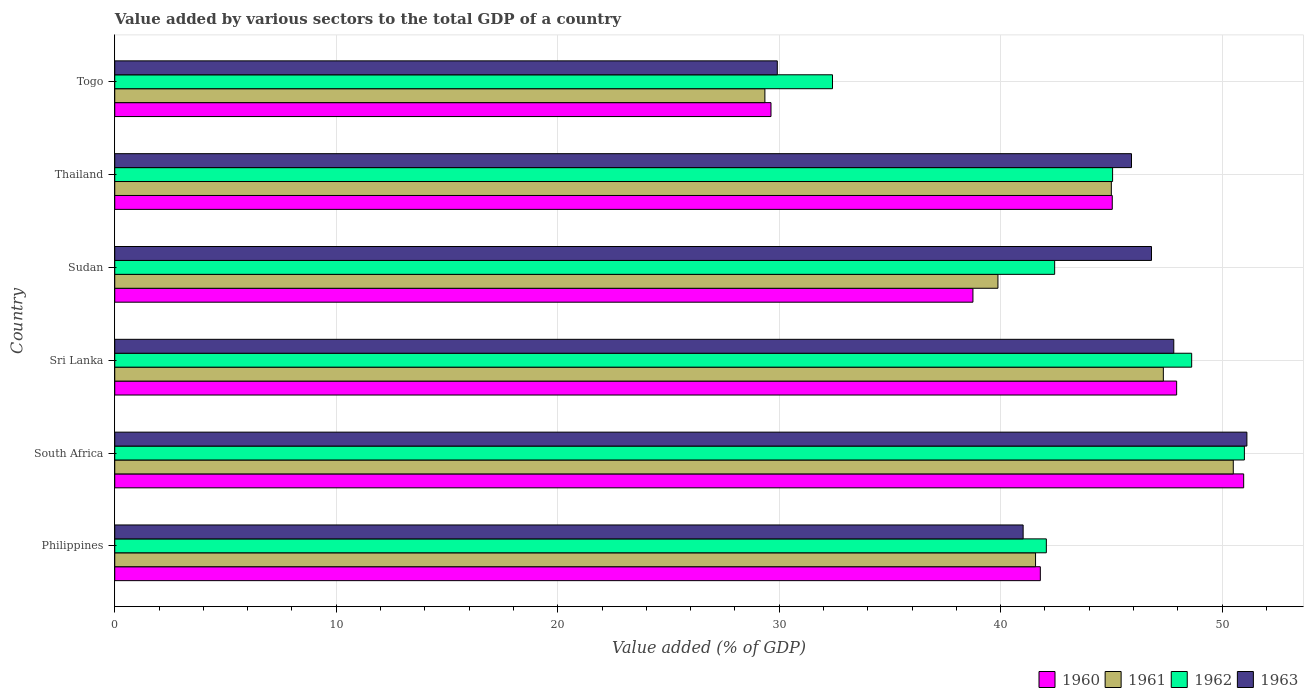How many groups of bars are there?
Make the answer very short. 6. Are the number of bars per tick equal to the number of legend labels?
Your response must be concise. Yes. Are the number of bars on each tick of the Y-axis equal?
Offer a terse response. Yes. How many bars are there on the 3rd tick from the top?
Ensure brevity in your answer.  4. What is the label of the 6th group of bars from the top?
Provide a succinct answer. Philippines. In how many cases, is the number of bars for a given country not equal to the number of legend labels?
Provide a short and direct response. 0. What is the value added by various sectors to the total GDP in 1962 in Togo?
Your response must be concise. 32.41. Across all countries, what is the maximum value added by various sectors to the total GDP in 1961?
Your answer should be compact. 50.5. Across all countries, what is the minimum value added by various sectors to the total GDP in 1961?
Your answer should be very brief. 29.35. In which country was the value added by various sectors to the total GDP in 1960 maximum?
Ensure brevity in your answer.  South Africa. In which country was the value added by various sectors to the total GDP in 1962 minimum?
Make the answer very short. Togo. What is the total value added by various sectors to the total GDP in 1961 in the graph?
Provide a succinct answer. 253.65. What is the difference between the value added by various sectors to the total GDP in 1962 in Philippines and that in Sri Lanka?
Make the answer very short. -6.56. What is the difference between the value added by various sectors to the total GDP in 1962 in Sri Lanka and the value added by various sectors to the total GDP in 1960 in Philippines?
Give a very brief answer. 6.83. What is the average value added by various sectors to the total GDP in 1960 per country?
Give a very brief answer. 42.35. What is the difference between the value added by various sectors to the total GDP in 1960 and value added by various sectors to the total GDP in 1962 in Sudan?
Offer a terse response. -3.69. What is the ratio of the value added by various sectors to the total GDP in 1961 in Sudan to that in Togo?
Make the answer very short. 1.36. Is the difference between the value added by various sectors to the total GDP in 1960 in Sri Lanka and Sudan greater than the difference between the value added by various sectors to the total GDP in 1962 in Sri Lanka and Sudan?
Offer a terse response. Yes. What is the difference between the highest and the second highest value added by various sectors to the total GDP in 1960?
Make the answer very short. 3.03. What is the difference between the highest and the lowest value added by various sectors to the total GDP in 1963?
Make the answer very short. 21.2. Is it the case that in every country, the sum of the value added by various sectors to the total GDP in 1960 and value added by various sectors to the total GDP in 1961 is greater than the value added by various sectors to the total GDP in 1963?
Provide a succinct answer. Yes. How many bars are there?
Ensure brevity in your answer.  24. How many countries are there in the graph?
Provide a short and direct response. 6. What is the title of the graph?
Ensure brevity in your answer.  Value added by various sectors to the total GDP of a country. Does "1985" appear as one of the legend labels in the graph?
Your answer should be compact. No. What is the label or title of the X-axis?
Keep it short and to the point. Value added (% of GDP). What is the label or title of the Y-axis?
Offer a very short reply. Country. What is the Value added (% of GDP) in 1960 in Philippines?
Provide a short and direct response. 41.79. What is the Value added (% of GDP) of 1961 in Philippines?
Your answer should be compact. 41.57. What is the Value added (% of GDP) of 1962 in Philippines?
Make the answer very short. 42.06. What is the Value added (% of GDP) in 1963 in Philippines?
Make the answer very short. 41.01. What is the Value added (% of GDP) of 1960 in South Africa?
Provide a short and direct response. 50.97. What is the Value added (% of GDP) in 1961 in South Africa?
Keep it short and to the point. 50.5. What is the Value added (% of GDP) in 1962 in South Africa?
Keep it short and to the point. 51.01. What is the Value added (% of GDP) in 1963 in South Africa?
Offer a terse response. 51.12. What is the Value added (% of GDP) of 1960 in Sri Lanka?
Offer a very short reply. 47.95. What is the Value added (% of GDP) in 1961 in Sri Lanka?
Provide a succinct answer. 47.35. What is the Value added (% of GDP) of 1962 in Sri Lanka?
Ensure brevity in your answer.  48.62. What is the Value added (% of GDP) of 1963 in Sri Lanka?
Keep it short and to the point. 47.82. What is the Value added (% of GDP) in 1960 in Sudan?
Offer a very short reply. 38.75. What is the Value added (% of GDP) in 1961 in Sudan?
Your response must be concise. 39.88. What is the Value added (% of GDP) of 1962 in Sudan?
Your answer should be very brief. 42.44. What is the Value added (% of GDP) in 1963 in Sudan?
Make the answer very short. 46.81. What is the Value added (% of GDP) of 1960 in Thailand?
Make the answer very short. 45.04. What is the Value added (% of GDP) of 1961 in Thailand?
Provide a short and direct response. 45. What is the Value added (% of GDP) of 1962 in Thailand?
Offer a terse response. 45.05. What is the Value added (% of GDP) of 1963 in Thailand?
Ensure brevity in your answer.  45.91. What is the Value added (% of GDP) in 1960 in Togo?
Ensure brevity in your answer.  29.63. What is the Value added (% of GDP) of 1961 in Togo?
Keep it short and to the point. 29.35. What is the Value added (% of GDP) of 1962 in Togo?
Give a very brief answer. 32.41. What is the Value added (% of GDP) of 1963 in Togo?
Make the answer very short. 29.91. Across all countries, what is the maximum Value added (% of GDP) of 1960?
Offer a very short reply. 50.97. Across all countries, what is the maximum Value added (% of GDP) of 1961?
Make the answer very short. 50.5. Across all countries, what is the maximum Value added (% of GDP) in 1962?
Ensure brevity in your answer.  51.01. Across all countries, what is the maximum Value added (% of GDP) in 1963?
Your answer should be very brief. 51.12. Across all countries, what is the minimum Value added (% of GDP) of 1960?
Give a very brief answer. 29.63. Across all countries, what is the minimum Value added (% of GDP) in 1961?
Your response must be concise. 29.35. Across all countries, what is the minimum Value added (% of GDP) of 1962?
Your response must be concise. 32.41. Across all countries, what is the minimum Value added (% of GDP) in 1963?
Provide a short and direct response. 29.91. What is the total Value added (% of GDP) in 1960 in the graph?
Give a very brief answer. 254.13. What is the total Value added (% of GDP) of 1961 in the graph?
Provide a succinct answer. 253.65. What is the total Value added (% of GDP) of 1962 in the graph?
Ensure brevity in your answer.  261.59. What is the total Value added (% of GDP) of 1963 in the graph?
Provide a short and direct response. 262.58. What is the difference between the Value added (% of GDP) in 1960 in Philippines and that in South Africa?
Make the answer very short. -9.18. What is the difference between the Value added (% of GDP) in 1961 in Philippines and that in South Africa?
Your response must be concise. -8.93. What is the difference between the Value added (% of GDP) of 1962 in Philippines and that in South Africa?
Give a very brief answer. -8.94. What is the difference between the Value added (% of GDP) in 1963 in Philippines and that in South Africa?
Offer a terse response. -10.1. What is the difference between the Value added (% of GDP) in 1960 in Philippines and that in Sri Lanka?
Ensure brevity in your answer.  -6.15. What is the difference between the Value added (% of GDP) in 1961 in Philippines and that in Sri Lanka?
Offer a very short reply. -5.77. What is the difference between the Value added (% of GDP) of 1962 in Philippines and that in Sri Lanka?
Ensure brevity in your answer.  -6.56. What is the difference between the Value added (% of GDP) in 1963 in Philippines and that in Sri Lanka?
Give a very brief answer. -6.8. What is the difference between the Value added (% of GDP) in 1960 in Philippines and that in Sudan?
Your response must be concise. 3.04. What is the difference between the Value added (% of GDP) of 1961 in Philippines and that in Sudan?
Your answer should be compact. 1.7. What is the difference between the Value added (% of GDP) of 1962 in Philippines and that in Sudan?
Offer a terse response. -0.38. What is the difference between the Value added (% of GDP) in 1963 in Philippines and that in Sudan?
Make the answer very short. -5.8. What is the difference between the Value added (% of GDP) in 1960 in Philippines and that in Thailand?
Make the answer very short. -3.25. What is the difference between the Value added (% of GDP) of 1961 in Philippines and that in Thailand?
Provide a short and direct response. -3.42. What is the difference between the Value added (% of GDP) in 1962 in Philippines and that in Thailand?
Your answer should be compact. -2.99. What is the difference between the Value added (% of GDP) in 1963 in Philippines and that in Thailand?
Provide a short and direct response. -4.89. What is the difference between the Value added (% of GDP) of 1960 in Philippines and that in Togo?
Provide a succinct answer. 12.16. What is the difference between the Value added (% of GDP) in 1961 in Philippines and that in Togo?
Offer a terse response. 12.22. What is the difference between the Value added (% of GDP) in 1962 in Philippines and that in Togo?
Provide a succinct answer. 9.66. What is the difference between the Value added (% of GDP) of 1963 in Philippines and that in Togo?
Provide a short and direct response. 11.1. What is the difference between the Value added (% of GDP) of 1960 in South Africa and that in Sri Lanka?
Make the answer very short. 3.03. What is the difference between the Value added (% of GDP) in 1961 in South Africa and that in Sri Lanka?
Your response must be concise. 3.16. What is the difference between the Value added (% of GDP) in 1962 in South Africa and that in Sri Lanka?
Your answer should be very brief. 2.38. What is the difference between the Value added (% of GDP) of 1963 in South Africa and that in Sri Lanka?
Make the answer very short. 3.3. What is the difference between the Value added (% of GDP) of 1960 in South Africa and that in Sudan?
Your answer should be very brief. 12.22. What is the difference between the Value added (% of GDP) in 1961 in South Africa and that in Sudan?
Provide a short and direct response. 10.63. What is the difference between the Value added (% of GDP) in 1962 in South Africa and that in Sudan?
Give a very brief answer. 8.57. What is the difference between the Value added (% of GDP) of 1963 in South Africa and that in Sudan?
Your answer should be very brief. 4.31. What is the difference between the Value added (% of GDP) of 1960 in South Africa and that in Thailand?
Offer a very short reply. 5.93. What is the difference between the Value added (% of GDP) of 1961 in South Africa and that in Thailand?
Your response must be concise. 5.51. What is the difference between the Value added (% of GDP) in 1962 in South Africa and that in Thailand?
Provide a short and direct response. 5.95. What is the difference between the Value added (% of GDP) in 1963 in South Africa and that in Thailand?
Provide a succinct answer. 5.21. What is the difference between the Value added (% of GDP) of 1960 in South Africa and that in Togo?
Offer a terse response. 21.34. What is the difference between the Value added (% of GDP) in 1961 in South Africa and that in Togo?
Offer a terse response. 21.15. What is the difference between the Value added (% of GDP) of 1962 in South Africa and that in Togo?
Provide a short and direct response. 18.6. What is the difference between the Value added (% of GDP) of 1963 in South Africa and that in Togo?
Make the answer very short. 21.2. What is the difference between the Value added (% of GDP) in 1960 in Sri Lanka and that in Sudan?
Offer a very short reply. 9.2. What is the difference between the Value added (% of GDP) in 1961 in Sri Lanka and that in Sudan?
Make the answer very short. 7.47. What is the difference between the Value added (% of GDP) of 1962 in Sri Lanka and that in Sudan?
Keep it short and to the point. 6.19. What is the difference between the Value added (% of GDP) in 1960 in Sri Lanka and that in Thailand?
Make the answer very short. 2.91. What is the difference between the Value added (% of GDP) of 1961 in Sri Lanka and that in Thailand?
Your answer should be very brief. 2.35. What is the difference between the Value added (% of GDP) of 1962 in Sri Lanka and that in Thailand?
Provide a short and direct response. 3.57. What is the difference between the Value added (% of GDP) in 1963 in Sri Lanka and that in Thailand?
Offer a very short reply. 1.91. What is the difference between the Value added (% of GDP) in 1960 in Sri Lanka and that in Togo?
Keep it short and to the point. 18.32. What is the difference between the Value added (% of GDP) of 1961 in Sri Lanka and that in Togo?
Your response must be concise. 17.99. What is the difference between the Value added (% of GDP) of 1962 in Sri Lanka and that in Togo?
Your response must be concise. 16.22. What is the difference between the Value added (% of GDP) of 1963 in Sri Lanka and that in Togo?
Your answer should be very brief. 17.9. What is the difference between the Value added (% of GDP) in 1960 in Sudan and that in Thailand?
Your answer should be very brief. -6.29. What is the difference between the Value added (% of GDP) in 1961 in Sudan and that in Thailand?
Offer a very short reply. -5.12. What is the difference between the Value added (% of GDP) in 1962 in Sudan and that in Thailand?
Ensure brevity in your answer.  -2.62. What is the difference between the Value added (% of GDP) of 1963 in Sudan and that in Thailand?
Make the answer very short. 0.9. What is the difference between the Value added (% of GDP) of 1960 in Sudan and that in Togo?
Your answer should be compact. 9.12. What is the difference between the Value added (% of GDP) in 1961 in Sudan and that in Togo?
Your answer should be compact. 10.52. What is the difference between the Value added (% of GDP) in 1962 in Sudan and that in Togo?
Give a very brief answer. 10.03. What is the difference between the Value added (% of GDP) of 1963 in Sudan and that in Togo?
Ensure brevity in your answer.  16.9. What is the difference between the Value added (% of GDP) in 1960 in Thailand and that in Togo?
Your answer should be very brief. 15.41. What is the difference between the Value added (% of GDP) in 1961 in Thailand and that in Togo?
Your answer should be very brief. 15.64. What is the difference between the Value added (% of GDP) of 1962 in Thailand and that in Togo?
Your response must be concise. 12.65. What is the difference between the Value added (% of GDP) in 1963 in Thailand and that in Togo?
Provide a short and direct response. 15.99. What is the difference between the Value added (% of GDP) of 1960 in Philippines and the Value added (% of GDP) of 1961 in South Africa?
Your answer should be very brief. -8.71. What is the difference between the Value added (% of GDP) in 1960 in Philippines and the Value added (% of GDP) in 1962 in South Africa?
Ensure brevity in your answer.  -9.21. What is the difference between the Value added (% of GDP) of 1960 in Philippines and the Value added (% of GDP) of 1963 in South Africa?
Ensure brevity in your answer.  -9.33. What is the difference between the Value added (% of GDP) in 1961 in Philippines and the Value added (% of GDP) in 1962 in South Africa?
Offer a terse response. -9.43. What is the difference between the Value added (% of GDP) in 1961 in Philippines and the Value added (% of GDP) in 1963 in South Africa?
Keep it short and to the point. -9.54. What is the difference between the Value added (% of GDP) in 1962 in Philippines and the Value added (% of GDP) in 1963 in South Africa?
Keep it short and to the point. -9.05. What is the difference between the Value added (% of GDP) of 1960 in Philippines and the Value added (% of GDP) of 1961 in Sri Lanka?
Your answer should be compact. -5.55. What is the difference between the Value added (% of GDP) in 1960 in Philippines and the Value added (% of GDP) in 1962 in Sri Lanka?
Offer a very short reply. -6.83. What is the difference between the Value added (% of GDP) in 1960 in Philippines and the Value added (% of GDP) in 1963 in Sri Lanka?
Your response must be concise. -6.03. What is the difference between the Value added (% of GDP) of 1961 in Philippines and the Value added (% of GDP) of 1962 in Sri Lanka?
Your answer should be very brief. -7.05. What is the difference between the Value added (% of GDP) in 1961 in Philippines and the Value added (% of GDP) in 1963 in Sri Lanka?
Offer a very short reply. -6.24. What is the difference between the Value added (% of GDP) in 1962 in Philippines and the Value added (% of GDP) in 1963 in Sri Lanka?
Your answer should be very brief. -5.75. What is the difference between the Value added (% of GDP) in 1960 in Philippines and the Value added (% of GDP) in 1961 in Sudan?
Make the answer very short. 1.91. What is the difference between the Value added (% of GDP) of 1960 in Philippines and the Value added (% of GDP) of 1962 in Sudan?
Give a very brief answer. -0.65. What is the difference between the Value added (% of GDP) of 1960 in Philippines and the Value added (% of GDP) of 1963 in Sudan?
Your answer should be compact. -5.02. What is the difference between the Value added (% of GDP) of 1961 in Philippines and the Value added (% of GDP) of 1962 in Sudan?
Make the answer very short. -0.86. What is the difference between the Value added (% of GDP) in 1961 in Philippines and the Value added (% of GDP) in 1963 in Sudan?
Offer a very short reply. -5.24. What is the difference between the Value added (% of GDP) of 1962 in Philippines and the Value added (% of GDP) of 1963 in Sudan?
Your answer should be very brief. -4.75. What is the difference between the Value added (% of GDP) in 1960 in Philippines and the Value added (% of GDP) in 1961 in Thailand?
Offer a terse response. -3.21. What is the difference between the Value added (% of GDP) of 1960 in Philippines and the Value added (% of GDP) of 1962 in Thailand?
Offer a very short reply. -3.26. What is the difference between the Value added (% of GDP) in 1960 in Philippines and the Value added (% of GDP) in 1963 in Thailand?
Make the answer very short. -4.12. What is the difference between the Value added (% of GDP) in 1961 in Philippines and the Value added (% of GDP) in 1962 in Thailand?
Provide a succinct answer. -3.48. What is the difference between the Value added (% of GDP) of 1961 in Philippines and the Value added (% of GDP) of 1963 in Thailand?
Your answer should be compact. -4.33. What is the difference between the Value added (% of GDP) in 1962 in Philippines and the Value added (% of GDP) in 1963 in Thailand?
Keep it short and to the point. -3.84. What is the difference between the Value added (% of GDP) in 1960 in Philippines and the Value added (% of GDP) in 1961 in Togo?
Ensure brevity in your answer.  12.44. What is the difference between the Value added (% of GDP) of 1960 in Philippines and the Value added (% of GDP) of 1962 in Togo?
Offer a terse response. 9.38. What is the difference between the Value added (% of GDP) of 1960 in Philippines and the Value added (% of GDP) of 1963 in Togo?
Your answer should be very brief. 11.88. What is the difference between the Value added (% of GDP) of 1961 in Philippines and the Value added (% of GDP) of 1962 in Togo?
Make the answer very short. 9.17. What is the difference between the Value added (% of GDP) of 1961 in Philippines and the Value added (% of GDP) of 1963 in Togo?
Offer a terse response. 11.66. What is the difference between the Value added (% of GDP) in 1962 in Philippines and the Value added (% of GDP) in 1963 in Togo?
Give a very brief answer. 12.15. What is the difference between the Value added (% of GDP) in 1960 in South Africa and the Value added (% of GDP) in 1961 in Sri Lanka?
Your response must be concise. 3.63. What is the difference between the Value added (% of GDP) in 1960 in South Africa and the Value added (% of GDP) in 1962 in Sri Lanka?
Provide a succinct answer. 2.35. What is the difference between the Value added (% of GDP) of 1960 in South Africa and the Value added (% of GDP) of 1963 in Sri Lanka?
Your answer should be very brief. 3.16. What is the difference between the Value added (% of GDP) of 1961 in South Africa and the Value added (% of GDP) of 1962 in Sri Lanka?
Ensure brevity in your answer.  1.88. What is the difference between the Value added (% of GDP) in 1961 in South Africa and the Value added (% of GDP) in 1963 in Sri Lanka?
Offer a very short reply. 2.69. What is the difference between the Value added (% of GDP) of 1962 in South Africa and the Value added (% of GDP) of 1963 in Sri Lanka?
Your answer should be compact. 3.19. What is the difference between the Value added (% of GDP) in 1960 in South Africa and the Value added (% of GDP) in 1961 in Sudan?
Your answer should be very brief. 11.09. What is the difference between the Value added (% of GDP) in 1960 in South Africa and the Value added (% of GDP) in 1962 in Sudan?
Keep it short and to the point. 8.53. What is the difference between the Value added (% of GDP) in 1960 in South Africa and the Value added (% of GDP) in 1963 in Sudan?
Offer a terse response. 4.16. What is the difference between the Value added (% of GDP) of 1961 in South Africa and the Value added (% of GDP) of 1962 in Sudan?
Offer a very short reply. 8.07. What is the difference between the Value added (% of GDP) in 1961 in South Africa and the Value added (% of GDP) in 1963 in Sudan?
Your answer should be very brief. 3.69. What is the difference between the Value added (% of GDP) in 1962 in South Africa and the Value added (% of GDP) in 1963 in Sudan?
Give a very brief answer. 4.19. What is the difference between the Value added (% of GDP) of 1960 in South Africa and the Value added (% of GDP) of 1961 in Thailand?
Ensure brevity in your answer.  5.98. What is the difference between the Value added (% of GDP) in 1960 in South Africa and the Value added (% of GDP) in 1962 in Thailand?
Your response must be concise. 5.92. What is the difference between the Value added (% of GDP) of 1960 in South Africa and the Value added (% of GDP) of 1963 in Thailand?
Your response must be concise. 5.06. What is the difference between the Value added (% of GDP) of 1961 in South Africa and the Value added (% of GDP) of 1962 in Thailand?
Offer a terse response. 5.45. What is the difference between the Value added (% of GDP) in 1961 in South Africa and the Value added (% of GDP) in 1963 in Thailand?
Your answer should be very brief. 4.6. What is the difference between the Value added (% of GDP) in 1962 in South Africa and the Value added (% of GDP) in 1963 in Thailand?
Provide a short and direct response. 5.1. What is the difference between the Value added (% of GDP) in 1960 in South Africa and the Value added (% of GDP) in 1961 in Togo?
Your answer should be very brief. 21.62. What is the difference between the Value added (% of GDP) of 1960 in South Africa and the Value added (% of GDP) of 1962 in Togo?
Offer a terse response. 18.56. What is the difference between the Value added (% of GDP) of 1960 in South Africa and the Value added (% of GDP) of 1963 in Togo?
Keep it short and to the point. 21.06. What is the difference between the Value added (% of GDP) in 1961 in South Africa and the Value added (% of GDP) in 1962 in Togo?
Offer a terse response. 18.1. What is the difference between the Value added (% of GDP) of 1961 in South Africa and the Value added (% of GDP) of 1963 in Togo?
Your response must be concise. 20.59. What is the difference between the Value added (% of GDP) in 1962 in South Africa and the Value added (% of GDP) in 1963 in Togo?
Keep it short and to the point. 21.09. What is the difference between the Value added (% of GDP) of 1960 in Sri Lanka and the Value added (% of GDP) of 1961 in Sudan?
Make the answer very short. 8.07. What is the difference between the Value added (% of GDP) of 1960 in Sri Lanka and the Value added (% of GDP) of 1962 in Sudan?
Provide a short and direct response. 5.51. What is the difference between the Value added (% of GDP) of 1960 in Sri Lanka and the Value added (% of GDP) of 1963 in Sudan?
Offer a very short reply. 1.14. What is the difference between the Value added (% of GDP) in 1961 in Sri Lanka and the Value added (% of GDP) in 1962 in Sudan?
Offer a very short reply. 4.91. What is the difference between the Value added (% of GDP) in 1961 in Sri Lanka and the Value added (% of GDP) in 1963 in Sudan?
Offer a very short reply. 0.53. What is the difference between the Value added (% of GDP) in 1962 in Sri Lanka and the Value added (% of GDP) in 1963 in Sudan?
Your response must be concise. 1.81. What is the difference between the Value added (% of GDP) of 1960 in Sri Lanka and the Value added (% of GDP) of 1961 in Thailand?
Ensure brevity in your answer.  2.95. What is the difference between the Value added (% of GDP) in 1960 in Sri Lanka and the Value added (% of GDP) in 1962 in Thailand?
Provide a succinct answer. 2.89. What is the difference between the Value added (% of GDP) in 1960 in Sri Lanka and the Value added (% of GDP) in 1963 in Thailand?
Keep it short and to the point. 2.04. What is the difference between the Value added (% of GDP) in 1961 in Sri Lanka and the Value added (% of GDP) in 1962 in Thailand?
Ensure brevity in your answer.  2.29. What is the difference between the Value added (% of GDP) in 1961 in Sri Lanka and the Value added (% of GDP) in 1963 in Thailand?
Your answer should be compact. 1.44. What is the difference between the Value added (% of GDP) in 1962 in Sri Lanka and the Value added (% of GDP) in 1963 in Thailand?
Provide a short and direct response. 2.72. What is the difference between the Value added (% of GDP) of 1960 in Sri Lanka and the Value added (% of GDP) of 1961 in Togo?
Offer a very short reply. 18.59. What is the difference between the Value added (% of GDP) in 1960 in Sri Lanka and the Value added (% of GDP) in 1962 in Togo?
Offer a terse response. 15.54. What is the difference between the Value added (% of GDP) of 1960 in Sri Lanka and the Value added (% of GDP) of 1963 in Togo?
Offer a terse response. 18.03. What is the difference between the Value added (% of GDP) in 1961 in Sri Lanka and the Value added (% of GDP) in 1962 in Togo?
Your answer should be compact. 14.94. What is the difference between the Value added (% of GDP) of 1961 in Sri Lanka and the Value added (% of GDP) of 1963 in Togo?
Provide a short and direct response. 17.43. What is the difference between the Value added (% of GDP) in 1962 in Sri Lanka and the Value added (% of GDP) in 1963 in Togo?
Keep it short and to the point. 18.71. What is the difference between the Value added (% of GDP) in 1960 in Sudan and the Value added (% of GDP) in 1961 in Thailand?
Your response must be concise. -6.25. What is the difference between the Value added (% of GDP) of 1960 in Sudan and the Value added (% of GDP) of 1962 in Thailand?
Provide a short and direct response. -6.31. What is the difference between the Value added (% of GDP) in 1960 in Sudan and the Value added (% of GDP) in 1963 in Thailand?
Offer a very short reply. -7.16. What is the difference between the Value added (% of GDP) in 1961 in Sudan and the Value added (% of GDP) in 1962 in Thailand?
Your answer should be compact. -5.18. What is the difference between the Value added (% of GDP) of 1961 in Sudan and the Value added (% of GDP) of 1963 in Thailand?
Your answer should be compact. -6.03. What is the difference between the Value added (% of GDP) of 1962 in Sudan and the Value added (% of GDP) of 1963 in Thailand?
Your answer should be compact. -3.47. What is the difference between the Value added (% of GDP) of 1960 in Sudan and the Value added (% of GDP) of 1961 in Togo?
Your response must be concise. 9.39. What is the difference between the Value added (% of GDP) in 1960 in Sudan and the Value added (% of GDP) in 1962 in Togo?
Your answer should be very brief. 6.34. What is the difference between the Value added (% of GDP) of 1960 in Sudan and the Value added (% of GDP) of 1963 in Togo?
Keep it short and to the point. 8.83. What is the difference between the Value added (% of GDP) in 1961 in Sudan and the Value added (% of GDP) in 1962 in Togo?
Your answer should be very brief. 7.47. What is the difference between the Value added (% of GDP) of 1961 in Sudan and the Value added (% of GDP) of 1963 in Togo?
Your response must be concise. 9.96. What is the difference between the Value added (% of GDP) in 1962 in Sudan and the Value added (% of GDP) in 1963 in Togo?
Keep it short and to the point. 12.52. What is the difference between the Value added (% of GDP) in 1960 in Thailand and the Value added (% of GDP) in 1961 in Togo?
Keep it short and to the point. 15.68. What is the difference between the Value added (% of GDP) in 1960 in Thailand and the Value added (% of GDP) in 1962 in Togo?
Provide a succinct answer. 12.63. What is the difference between the Value added (% of GDP) of 1960 in Thailand and the Value added (% of GDP) of 1963 in Togo?
Offer a very short reply. 15.12. What is the difference between the Value added (% of GDP) of 1961 in Thailand and the Value added (% of GDP) of 1962 in Togo?
Ensure brevity in your answer.  12.59. What is the difference between the Value added (% of GDP) of 1961 in Thailand and the Value added (% of GDP) of 1963 in Togo?
Provide a short and direct response. 15.08. What is the difference between the Value added (% of GDP) of 1962 in Thailand and the Value added (% of GDP) of 1963 in Togo?
Your answer should be very brief. 15.14. What is the average Value added (% of GDP) of 1960 per country?
Make the answer very short. 42.35. What is the average Value added (% of GDP) in 1961 per country?
Make the answer very short. 42.28. What is the average Value added (% of GDP) of 1962 per country?
Offer a very short reply. 43.6. What is the average Value added (% of GDP) of 1963 per country?
Give a very brief answer. 43.76. What is the difference between the Value added (% of GDP) in 1960 and Value added (% of GDP) in 1961 in Philippines?
Make the answer very short. 0.22. What is the difference between the Value added (% of GDP) of 1960 and Value added (% of GDP) of 1962 in Philippines?
Offer a very short reply. -0.27. What is the difference between the Value added (% of GDP) in 1960 and Value added (% of GDP) in 1963 in Philippines?
Your answer should be compact. 0.78. What is the difference between the Value added (% of GDP) of 1961 and Value added (% of GDP) of 1962 in Philippines?
Offer a very short reply. -0.49. What is the difference between the Value added (% of GDP) of 1961 and Value added (% of GDP) of 1963 in Philippines?
Make the answer very short. 0.56. What is the difference between the Value added (% of GDP) of 1962 and Value added (% of GDP) of 1963 in Philippines?
Ensure brevity in your answer.  1.05. What is the difference between the Value added (% of GDP) of 1960 and Value added (% of GDP) of 1961 in South Africa?
Your answer should be compact. 0.47. What is the difference between the Value added (% of GDP) in 1960 and Value added (% of GDP) in 1962 in South Africa?
Keep it short and to the point. -0.03. What is the difference between the Value added (% of GDP) in 1960 and Value added (% of GDP) in 1963 in South Africa?
Your response must be concise. -0.15. What is the difference between the Value added (% of GDP) in 1961 and Value added (% of GDP) in 1962 in South Africa?
Give a very brief answer. -0.5. What is the difference between the Value added (% of GDP) of 1961 and Value added (% of GDP) of 1963 in South Africa?
Your response must be concise. -0.61. What is the difference between the Value added (% of GDP) of 1962 and Value added (% of GDP) of 1963 in South Africa?
Your answer should be compact. -0.11. What is the difference between the Value added (% of GDP) in 1960 and Value added (% of GDP) in 1961 in Sri Lanka?
Offer a very short reply. 0.6. What is the difference between the Value added (% of GDP) in 1960 and Value added (% of GDP) in 1962 in Sri Lanka?
Give a very brief answer. -0.68. What is the difference between the Value added (% of GDP) in 1960 and Value added (% of GDP) in 1963 in Sri Lanka?
Your response must be concise. 0.13. What is the difference between the Value added (% of GDP) of 1961 and Value added (% of GDP) of 1962 in Sri Lanka?
Keep it short and to the point. -1.28. What is the difference between the Value added (% of GDP) in 1961 and Value added (% of GDP) in 1963 in Sri Lanka?
Your answer should be compact. -0.47. What is the difference between the Value added (% of GDP) of 1962 and Value added (% of GDP) of 1963 in Sri Lanka?
Make the answer very short. 0.81. What is the difference between the Value added (% of GDP) of 1960 and Value added (% of GDP) of 1961 in Sudan?
Ensure brevity in your answer.  -1.13. What is the difference between the Value added (% of GDP) in 1960 and Value added (% of GDP) in 1962 in Sudan?
Your response must be concise. -3.69. What is the difference between the Value added (% of GDP) of 1960 and Value added (% of GDP) of 1963 in Sudan?
Make the answer very short. -8.06. What is the difference between the Value added (% of GDP) in 1961 and Value added (% of GDP) in 1962 in Sudan?
Ensure brevity in your answer.  -2.56. What is the difference between the Value added (% of GDP) of 1961 and Value added (% of GDP) of 1963 in Sudan?
Your answer should be compact. -6.93. What is the difference between the Value added (% of GDP) in 1962 and Value added (% of GDP) in 1963 in Sudan?
Your answer should be compact. -4.37. What is the difference between the Value added (% of GDP) of 1960 and Value added (% of GDP) of 1961 in Thailand?
Offer a very short reply. 0.04. What is the difference between the Value added (% of GDP) in 1960 and Value added (% of GDP) in 1962 in Thailand?
Your answer should be very brief. -0.02. What is the difference between the Value added (% of GDP) of 1960 and Value added (% of GDP) of 1963 in Thailand?
Your response must be concise. -0.87. What is the difference between the Value added (% of GDP) in 1961 and Value added (% of GDP) in 1962 in Thailand?
Offer a terse response. -0.06. What is the difference between the Value added (% of GDP) in 1961 and Value added (% of GDP) in 1963 in Thailand?
Ensure brevity in your answer.  -0.91. What is the difference between the Value added (% of GDP) of 1962 and Value added (% of GDP) of 1963 in Thailand?
Your answer should be very brief. -0.85. What is the difference between the Value added (% of GDP) of 1960 and Value added (% of GDP) of 1961 in Togo?
Offer a very short reply. 0.27. What is the difference between the Value added (% of GDP) of 1960 and Value added (% of GDP) of 1962 in Togo?
Keep it short and to the point. -2.78. What is the difference between the Value added (% of GDP) in 1960 and Value added (% of GDP) in 1963 in Togo?
Keep it short and to the point. -0.28. What is the difference between the Value added (% of GDP) in 1961 and Value added (% of GDP) in 1962 in Togo?
Your answer should be compact. -3.05. What is the difference between the Value added (% of GDP) in 1961 and Value added (% of GDP) in 1963 in Togo?
Offer a very short reply. -0.56. What is the difference between the Value added (% of GDP) in 1962 and Value added (% of GDP) in 1963 in Togo?
Your response must be concise. 2.49. What is the ratio of the Value added (% of GDP) in 1960 in Philippines to that in South Africa?
Provide a short and direct response. 0.82. What is the ratio of the Value added (% of GDP) of 1961 in Philippines to that in South Africa?
Give a very brief answer. 0.82. What is the ratio of the Value added (% of GDP) in 1962 in Philippines to that in South Africa?
Your response must be concise. 0.82. What is the ratio of the Value added (% of GDP) in 1963 in Philippines to that in South Africa?
Your answer should be compact. 0.8. What is the ratio of the Value added (% of GDP) in 1960 in Philippines to that in Sri Lanka?
Give a very brief answer. 0.87. What is the ratio of the Value added (% of GDP) in 1961 in Philippines to that in Sri Lanka?
Your answer should be compact. 0.88. What is the ratio of the Value added (% of GDP) in 1962 in Philippines to that in Sri Lanka?
Offer a very short reply. 0.87. What is the ratio of the Value added (% of GDP) of 1963 in Philippines to that in Sri Lanka?
Keep it short and to the point. 0.86. What is the ratio of the Value added (% of GDP) in 1960 in Philippines to that in Sudan?
Provide a succinct answer. 1.08. What is the ratio of the Value added (% of GDP) of 1961 in Philippines to that in Sudan?
Give a very brief answer. 1.04. What is the ratio of the Value added (% of GDP) of 1963 in Philippines to that in Sudan?
Offer a terse response. 0.88. What is the ratio of the Value added (% of GDP) of 1960 in Philippines to that in Thailand?
Make the answer very short. 0.93. What is the ratio of the Value added (% of GDP) of 1961 in Philippines to that in Thailand?
Your answer should be very brief. 0.92. What is the ratio of the Value added (% of GDP) in 1962 in Philippines to that in Thailand?
Give a very brief answer. 0.93. What is the ratio of the Value added (% of GDP) in 1963 in Philippines to that in Thailand?
Your answer should be very brief. 0.89. What is the ratio of the Value added (% of GDP) in 1960 in Philippines to that in Togo?
Make the answer very short. 1.41. What is the ratio of the Value added (% of GDP) of 1961 in Philippines to that in Togo?
Give a very brief answer. 1.42. What is the ratio of the Value added (% of GDP) of 1962 in Philippines to that in Togo?
Make the answer very short. 1.3. What is the ratio of the Value added (% of GDP) in 1963 in Philippines to that in Togo?
Your response must be concise. 1.37. What is the ratio of the Value added (% of GDP) of 1960 in South Africa to that in Sri Lanka?
Your response must be concise. 1.06. What is the ratio of the Value added (% of GDP) of 1961 in South Africa to that in Sri Lanka?
Keep it short and to the point. 1.07. What is the ratio of the Value added (% of GDP) of 1962 in South Africa to that in Sri Lanka?
Offer a terse response. 1.05. What is the ratio of the Value added (% of GDP) of 1963 in South Africa to that in Sri Lanka?
Offer a very short reply. 1.07. What is the ratio of the Value added (% of GDP) in 1960 in South Africa to that in Sudan?
Provide a short and direct response. 1.32. What is the ratio of the Value added (% of GDP) in 1961 in South Africa to that in Sudan?
Your response must be concise. 1.27. What is the ratio of the Value added (% of GDP) of 1962 in South Africa to that in Sudan?
Provide a succinct answer. 1.2. What is the ratio of the Value added (% of GDP) of 1963 in South Africa to that in Sudan?
Keep it short and to the point. 1.09. What is the ratio of the Value added (% of GDP) of 1960 in South Africa to that in Thailand?
Your answer should be compact. 1.13. What is the ratio of the Value added (% of GDP) in 1961 in South Africa to that in Thailand?
Give a very brief answer. 1.12. What is the ratio of the Value added (% of GDP) in 1962 in South Africa to that in Thailand?
Provide a succinct answer. 1.13. What is the ratio of the Value added (% of GDP) of 1963 in South Africa to that in Thailand?
Provide a short and direct response. 1.11. What is the ratio of the Value added (% of GDP) in 1960 in South Africa to that in Togo?
Ensure brevity in your answer.  1.72. What is the ratio of the Value added (% of GDP) of 1961 in South Africa to that in Togo?
Your answer should be very brief. 1.72. What is the ratio of the Value added (% of GDP) of 1962 in South Africa to that in Togo?
Provide a short and direct response. 1.57. What is the ratio of the Value added (% of GDP) in 1963 in South Africa to that in Togo?
Give a very brief answer. 1.71. What is the ratio of the Value added (% of GDP) in 1960 in Sri Lanka to that in Sudan?
Your answer should be compact. 1.24. What is the ratio of the Value added (% of GDP) in 1961 in Sri Lanka to that in Sudan?
Your response must be concise. 1.19. What is the ratio of the Value added (% of GDP) of 1962 in Sri Lanka to that in Sudan?
Ensure brevity in your answer.  1.15. What is the ratio of the Value added (% of GDP) in 1963 in Sri Lanka to that in Sudan?
Offer a terse response. 1.02. What is the ratio of the Value added (% of GDP) in 1960 in Sri Lanka to that in Thailand?
Your response must be concise. 1.06. What is the ratio of the Value added (% of GDP) of 1961 in Sri Lanka to that in Thailand?
Your answer should be very brief. 1.05. What is the ratio of the Value added (% of GDP) in 1962 in Sri Lanka to that in Thailand?
Give a very brief answer. 1.08. What is the ratio of the Value added (% of GDP) of 1963 in Sri Lanka to that in Thailand?
Keep it short and to the point. 1.04. What is the ratio of the Value added (% of GDP) of 1960 in Sri Lanka to that in Togo?
Your answer should be compact. 1.62. What is the ratio of the Value added (% of GDP) of 1961 in Sri Lanka to that in Togo?
Make the answer very short. 1.61. What is the ratio of the Value added (% of GDP) in 1962 in Sri Lanka to that in Togo?
Your response must be concise. 1.5. What is the ratio of the Value added (% of GDP) of 1963 in Sri Lanka to that in Togo?
Your answer should be very brief. 1.6. What is the ratio of the Value added (% of GDP) in 1960 in Sudan to that in Thailand?
Keep it short and to the point. 0.86. What is the ratio of the Value added (% of GDP) in 1961 in Sudan to that in Thailand?
Offer a very short reply. 0.89. What is the ratio of the Value added (% of GDP) in 1962 in Sudan to that in Thailand?
Give a very brief answer. 0.94. What is the ratio of the Value added (% of GDP) of 1963 in Sudan to that in Thailand?
Your answer should be compact. 1.02. What is the ratio of the Value added (% of GDP) in 1960 in Sudan to that in Togo?
Keep it short and to the point. 1.31. What is the ratio of the Value added (% of GDP) of 1961 in Sudan to that in Togo?
Keep it short and to the point. 1.36. What is the ratio of the Value added (% of GDP) of 1962 in Sudan to that in Togo?
Your response must be concise. 1.31. What is the ratio of the Value added (% of GDP) of 1963 in Sudan to that in Togo?
Ensure brevity in your answer.  1.56. What is the ratio of the Value added (% of GDP) of 1960 in Thailand to that in Togo?
Offer a terse response. 1.52. What is the ratio of the Value added (% of GDP) in 1961 in Thailand to that in Togo?
Provide a short and direct response. 1.53. What is the ratio of the Value added (% of GDP) of 1962 in Thailand to that in Togo?
Make the answer very short. 1.39. What is the ratio of the Value added (% of GDP) of 1963 in Thailand to that in Togo?
Ensure brevity in your answer.  1.53. What is the difference between the highest and the second highest Value added (% of GDP) of 1960?
Offer a very short reply. 3.03. What is the difference between the highest and the second highest Value added (% of GDP) of 1961?
Give a very brief answer. 3.16. What is the difference between the highest and the second highest Value added (% of GDP) in 1962?
Your answer should be compact. 2.38. What is the difference between the highest and the second highest Value added (% of GDP) of 1963?
Make the answer very short. 3.3. What is the difference between the highest and the lowest Value added (% of GDP) of 1960?
Offer a terse response. 21.34. What is the difference between the highest and the lowest Value added (% of GDP) of 1961?
Provide a short and direct response. 21.15. What is the difference between the highest and the lowest Value added (% of GDP) of 1962?
Offer a very short reply. 18.6. What is the difference between the highest and the lowest Value added (% of GDP) in 1963?
Offer a very short reply. 21.2. 